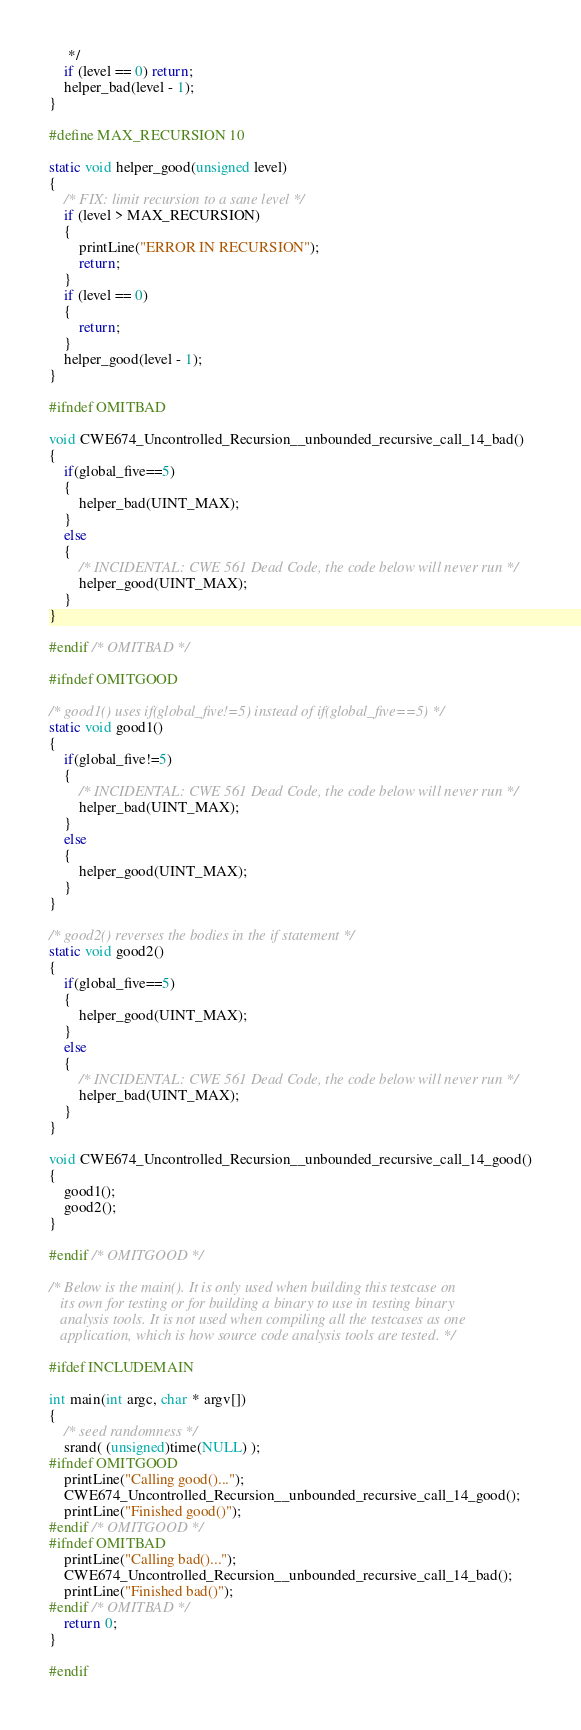Convert code to text. <code><loc_0><loc_0><loc_500><loc_500><_C_>     */
    if (level == 0) return;
    helper_bad(level - 1);
}

#define MAX_RECURSION 10

static void helper_good(unsigned level)
{
    /* FIX: limit recursion to a sane level */
    if (level > MAX_RECURSION)
    {
        printLine("ERROR IN RECURSION");
        return;
    }
    if (level == 0)
    {
        return;
    }
    helper_good(level - 1);
}

#ifndef OMITBAD

void CWE674_Uncontrolled_Recursion__unbounded_recursive_call_14_bad()
{
    if(global_five==5)
    {
        helper_bad(UINT_MAX);
    }
    else
    {
        /* INCIDENTAL: CWE 561 Dead Code, the code below will never run */
        helper_good(UINT_MAX);
    }
}

#endif /* OMITBAD */

#ifndef OMITGOOD

/* good1() uses if(global_five!=5) instead of if(global_five==5) */
static void good1()
{
    if(global_five!=5)
    {
        /* INCIDENTAL: CWE 561 Dead Code, the code below will never run */
        helper_bad(UINT_MAX);
    }
    else
    {
        helper_good(UINT_MAX);
    }
}

/* good2() reverses the bodies in the if statement */
static void good2()
{
    if(global_five==5)
    {
        helper_good(UINT_MAX);
    }
    else
    {
        /* INCIDENTAL: CWE 561 Dead Code, the code below will never run */
        helper_bad(UINT_MAX);
    }
}

void CWE674_Uncontrolled_Recursion__unbounded_recursive_call_14_good()
{
    good1();
    good2();
}

#endif /* OMITGOOD */

/* Below is the main(). It is only used when building this testcase on
   its own for testing or for building a binary to use in testing binary
   analysis tools. It is not used when compiling all the testcases as one
   application, which is how source code analysis tools are tested. */

#ifdef INCLUDEMAIN

int main(int argc, char * argv[])
{
    /* seed randomness */
    srand( (unsigned)time(NULL) );
#ifndef OMITGOOD
    printLine("Calling good()...");
    CWE674_Uncontrolled_Recursion__unbounded_recursive_call_14_good();
    printLine("Finished good()");
#endif /* OMITGOOD */
#ifndef OMITBAD
    printLine("Calling bad()...");
    CWE674_Uncontrolled_Recursion__unbounded_recursive_call_14_bad();
    printLine("Finished bad()");
#endif /* OMITBAD */
    return 0;
}

#endif
</code> 